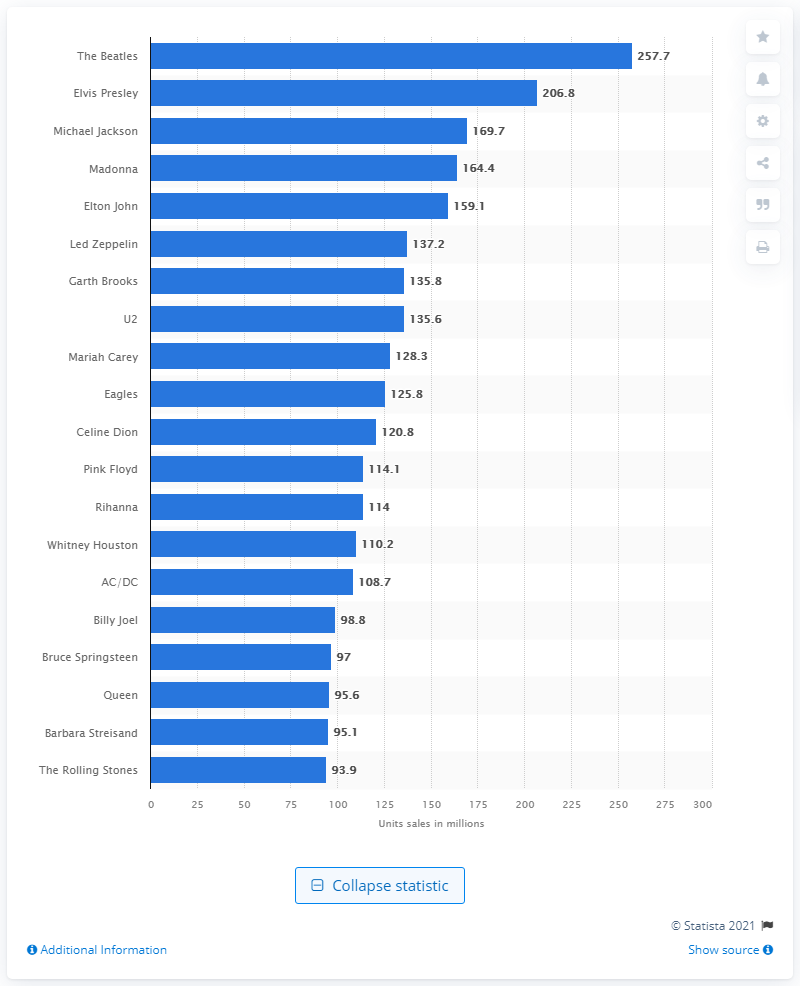Specify some key components in this picture. The Beatles had 257.7 certified sales. Elvis Presley had 206.8 certified sales. Garth Brooks, an American singer-songwriter, is known for his contributions to the country music genre. Michael Jackson had 169.7 sales. 